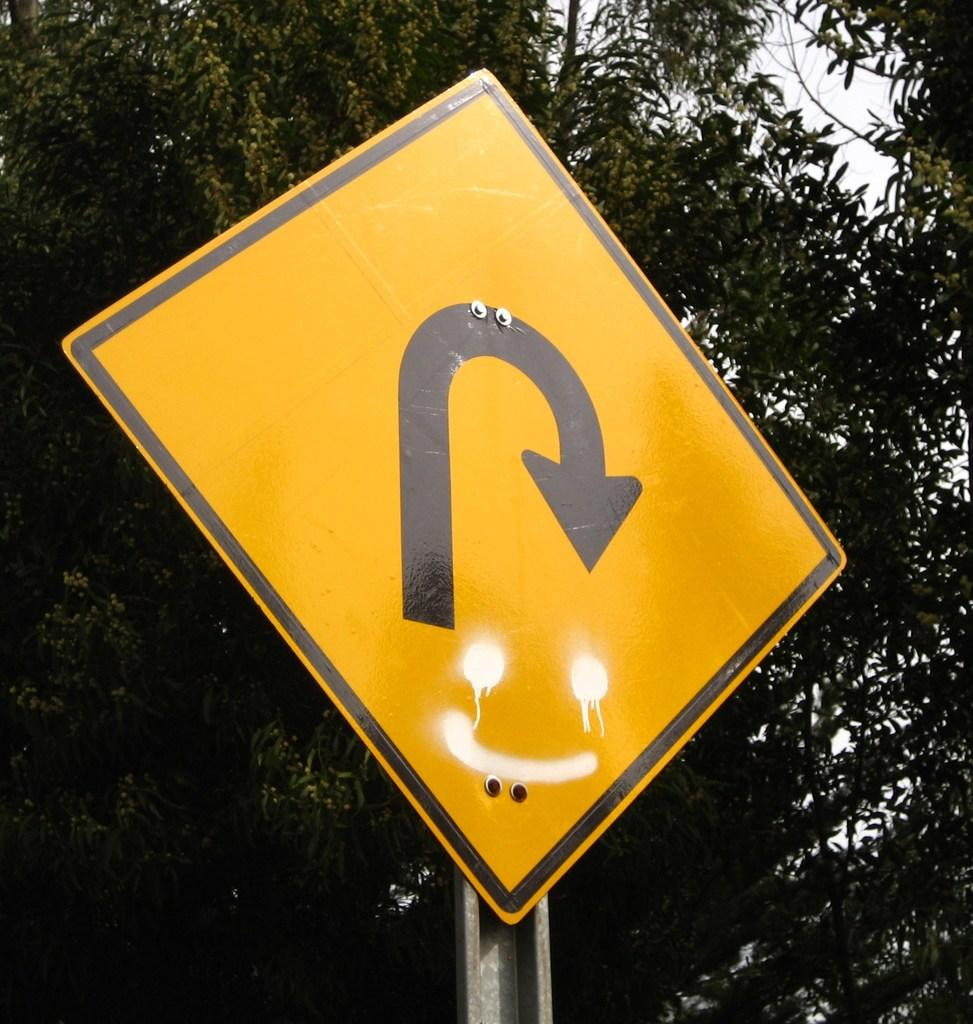What is the main object in the image? There is a pole in the image. What is attached to the pole? The pole has a yellow sign board. What can be seen in the background of the image? There are trees and the sky visible in the background of the image. What type of sock is the judge wearing in the image? There is no judge or sock present in the image. How does the sun affect the visibility of the yellow sign board in the image? The image does not provide information about the sun's position or its effect on the visibility of the yellow sign board. 